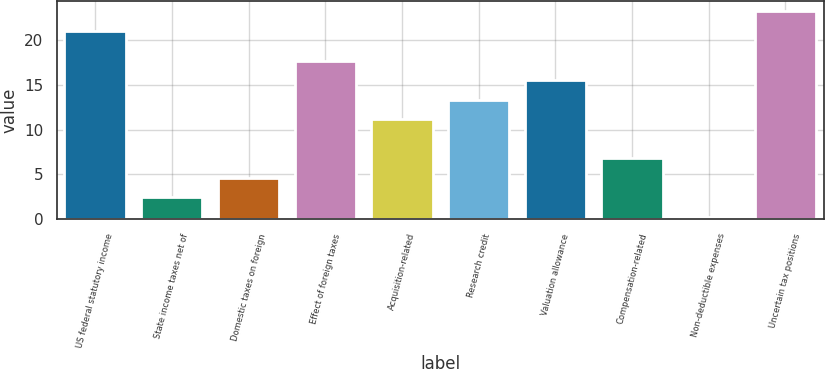Convert chart to OTSL. <chart><loc_0><loc_0><loc_500><loc_500><bar_chart><fcel>US federal statutory income<fcel>State income taxes net of<fcel>Domestic taxes on foreign<fcel>Effect of foreign taxes<fcel>Acquisition-related<fcel>Research credit<fcel>Valuation allowance<fcel>Compensation-related<fcel>Non-deductible expenses<fcel>Uncertain tax positions<nl><fcel>21<fcel>2.47<fcel>4.64<fcel>17.66<fcel>11.15<fcel>13.32<fcel>15.49<fcel>6.81<fcel>0.3<fcel>23.17<nl></chart> 